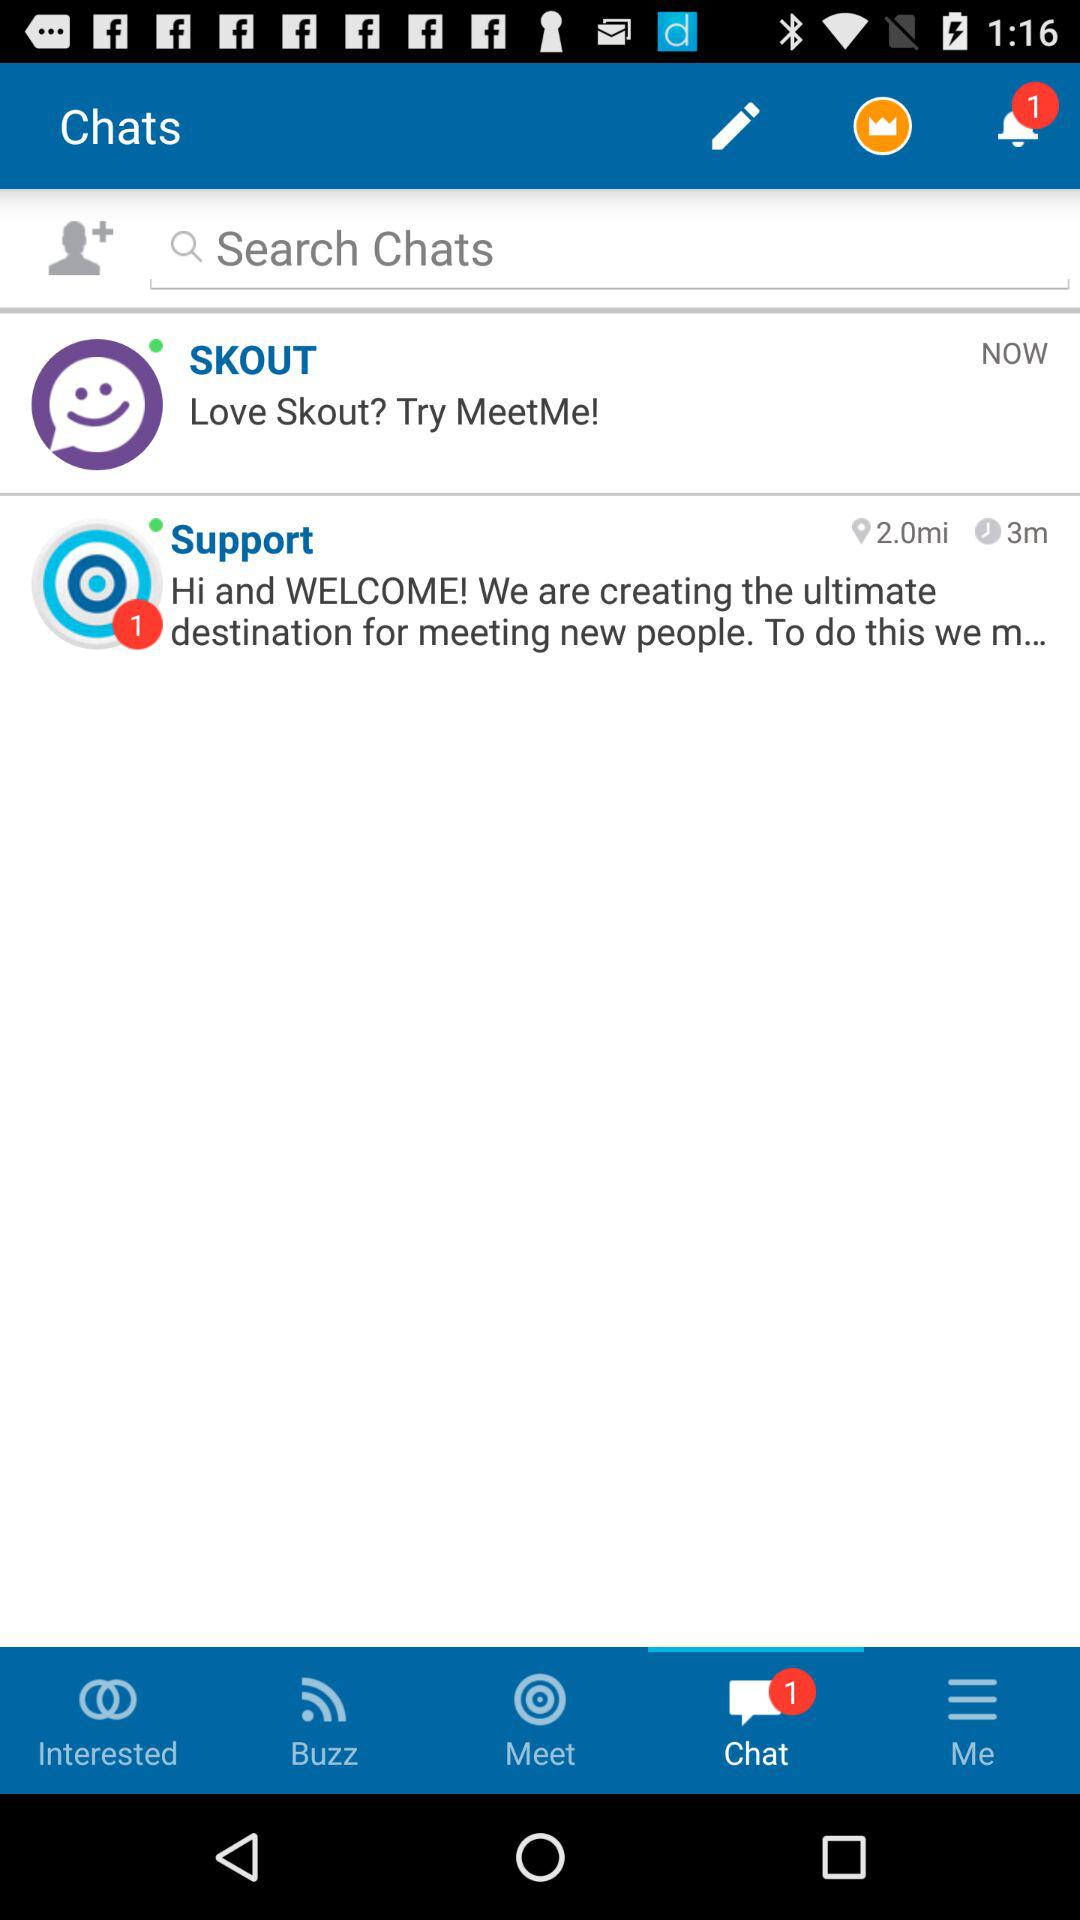What is the number of the notification? The number of the notification is 1. 